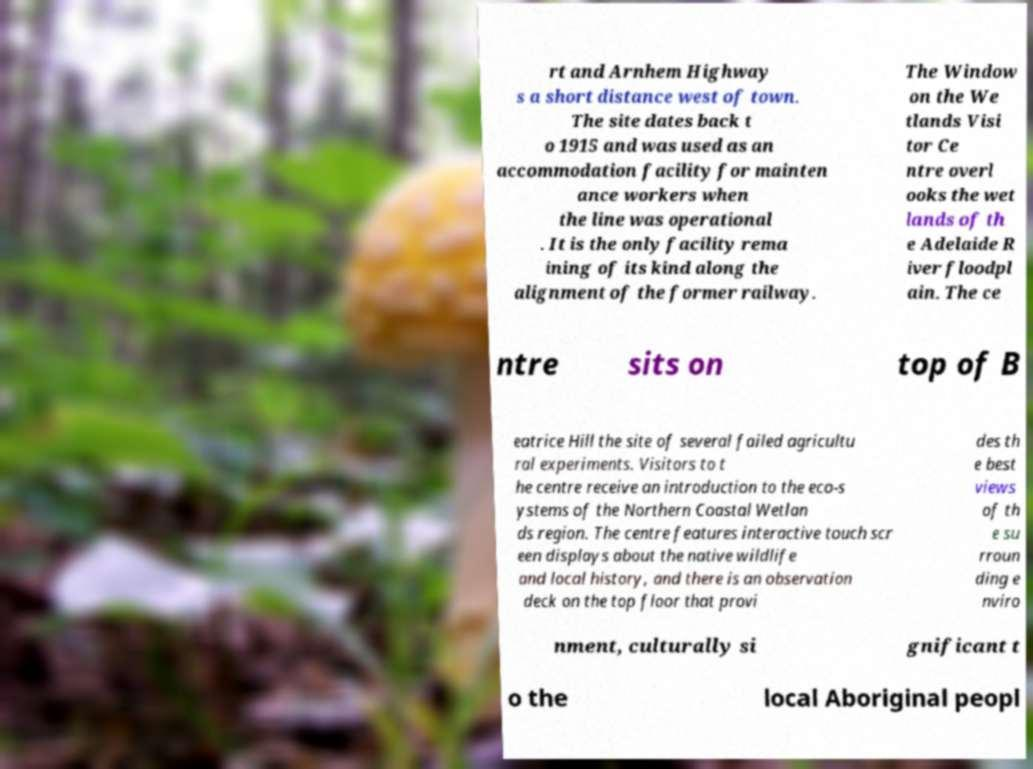Could you assist in decoding the text presented in this image and type it out clearly? rt and Arnhem Highway s a short distance west of town. The site dates back t o 1915 and was used as an accommodation facility for mainten ance workers when the line was operational . It is the only facility rema ining of its kind along the alignment of the former railway. The Window on the We tlands Visi tor Ce ntre overl ooks the wet lands of th e Adelaide R iver floodpl ain. The ce ntre sits on top of B eatrice Hill the site of several failed agricultu ral experiments. Visitors to t he centre receive an introduction to the eco-s ystems of the Northern Coastal Wetlan ds region. The centre features interactive touch scr een displays about the native wildlife and local history, and there is an observation deck on the top floor that provi des th e best views of th e su rroun ding e nviro nment, culturally si gnificant t o the local Aboriginal peopl 